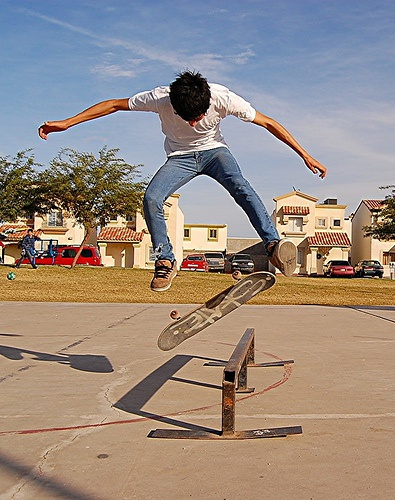Describe the objects in this image and their specific colors. I can see people in gray, black, and white tones, skateboard in gray, maroon, and tan tones, car in gray, brown, black, and maroon tones, truck in gray, brown, maroon, and black tones, and car in gray, brown, maroon, and black tones in this image. 